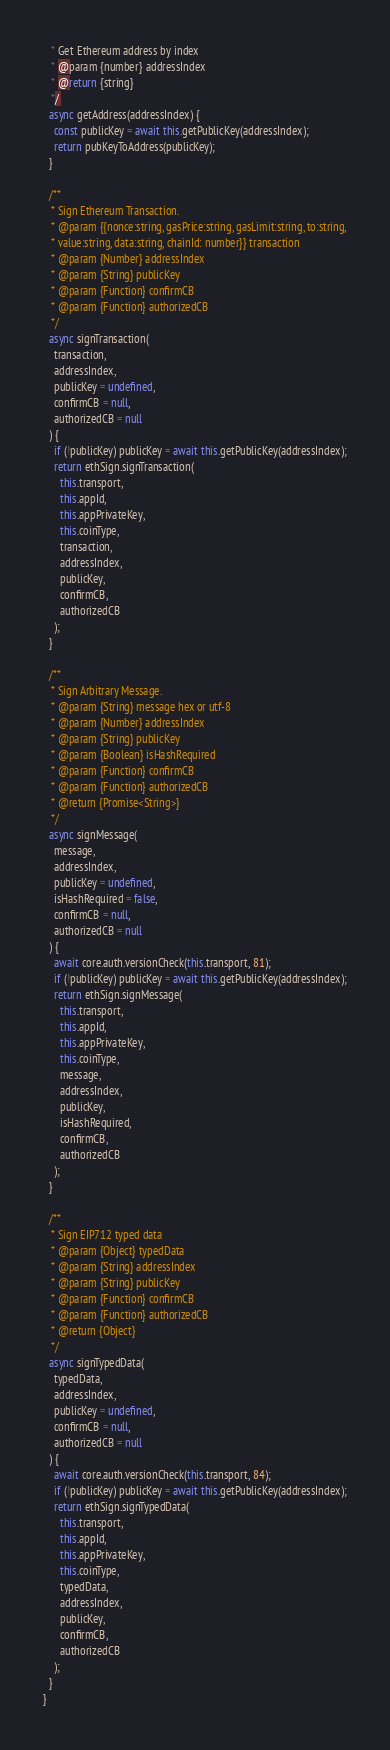Convert code to text. <code><loc_0><loc_0><loc_500><loc_500><_JavaScript_>   * Get Ethereum address by index
   * @param {number} addressIndex
   * @return {string}
   */
  async getAddress(addressIndex) {
    const publicKey = await this.getPublicKey(addressIndex);
    return pubKeyToAddress(publicKey);
  }

  /**
   * Sign Ethereum Transaction.
   * @param {{nonce:string, gasPrice:string, gasLimit:string, to:string,
   * value:string, data:string, chainId: number}} transaction
   * @param {Number} addressIndex
   * @param {String} publicKey
   * @param {Function} confirmCB
   * @param {Function} authorizedCB
   */
  async signTransaction(
    transaction,
    addressIndex,
    publicKey = undefined,
    confirmCB = null,
    authorizedCB = null
  ) {
    if (!publicKey) publicKey = await this.getPublicKey(addressIndex);
    return ethSign.signTransaction(
      this.transport,
      this.appId,
      this.appPrivateKey,
      this.coinType,
      transaction,
      addressIndex,
      publicKey,
      confirmCB,
      authorizedCB
    );
  }

  /**
   * Sign Arbitrary Message.
   * @param {String} message hex or utf-8
   * @param {Number} addressIndex
   * @param {String} publicKey
   * @param {Boolean} isHashRequired
   * @param {Function} confirmCB
   * @param {Function} authorizedCB
   * @return {Promise<String>}
   */
  async signMessage(
    message,
    addressIndex,
    publicKey = undefined,
    isHashRequired = false,
    confirmCB = null,
    authorizedCB = null
  ) {
    await core.auth.versionCheck(this.transport, 81);
    if (!publicKey) publicKey = await this.getPublicKey(addressIndex);
    return ethSign.signMessage(
      this.transport,
      this.appId,
      this.appPrivateKey,
      this.coinType,
      message,
      addressIndex,
      publicKey,
      isHashRequired,
      confirmCB,
      authorizedCB
    );
  }

  /**
   * Sign EIP712 typed data
   * @param {Object} typedData
   * @param {String} addressIndex
   * @param {String} publicKey
   * @param {Function} confirmCB
   * @param {Function} authorizedCB
   * @return {Object}
   */
  async signTypedData(
    typedData,
    addressIndex,
    publicKey = undefined,
    confirmCB = null,
    authorizedCB = null
  ) {
    await core.auth.versionCheck(this.transport, 84);
    if (!publicKey) publicKey = await this.getPublicKey(addressIndex);
    return ethSign.signTypedData(
      this.transport,
      this.appId,
      this.appPrivateKey,
      this.coinType,
      typedData,
      addressIndex,
      publicKey,
      confirmCB,
      authorizedCB
    );
  }
}
</code> 